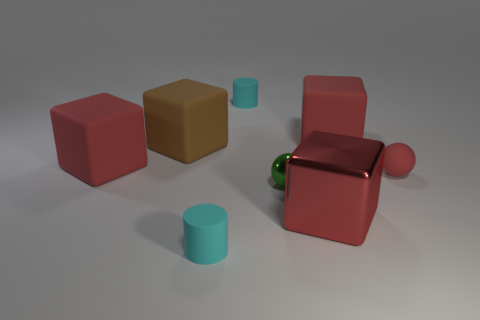There is a red matte thing that is the same shape as the small metal thing; what is its size?
Provide a short and direct response. Small. What number of large brown objects have the same material as the tiny red thing?
Ensure brevity in your answer.  1. What number of large rubber cubes have the same color as the big shiny cube?
Ensure brevity in your answer.  2. What number of things are big cubes that are on the right side of the big metal cube or cubes behind the brown block?
Offer a terse response. 1. Are there fewer small red matte objects that are to the left of the tiny shiny thing than brown matte blocks?
Keep it short and to the point. Yes. Is there a cyan thing that has the same size as the brown matte cube?
Give a very brief answer. No. The large metallic block is what color?
Make the answer very short. Red. Do the red metallic thing and the brown object have the same size?
Give a very brief answer. Yes. How many objects are red objects or tiny cyan matte cylinders?
Ensure brevity in your answer.  6. Is the number of small cyan objects that are behind the green object the same as the number of large red metal cylinders?
Offer a terse response. No. 